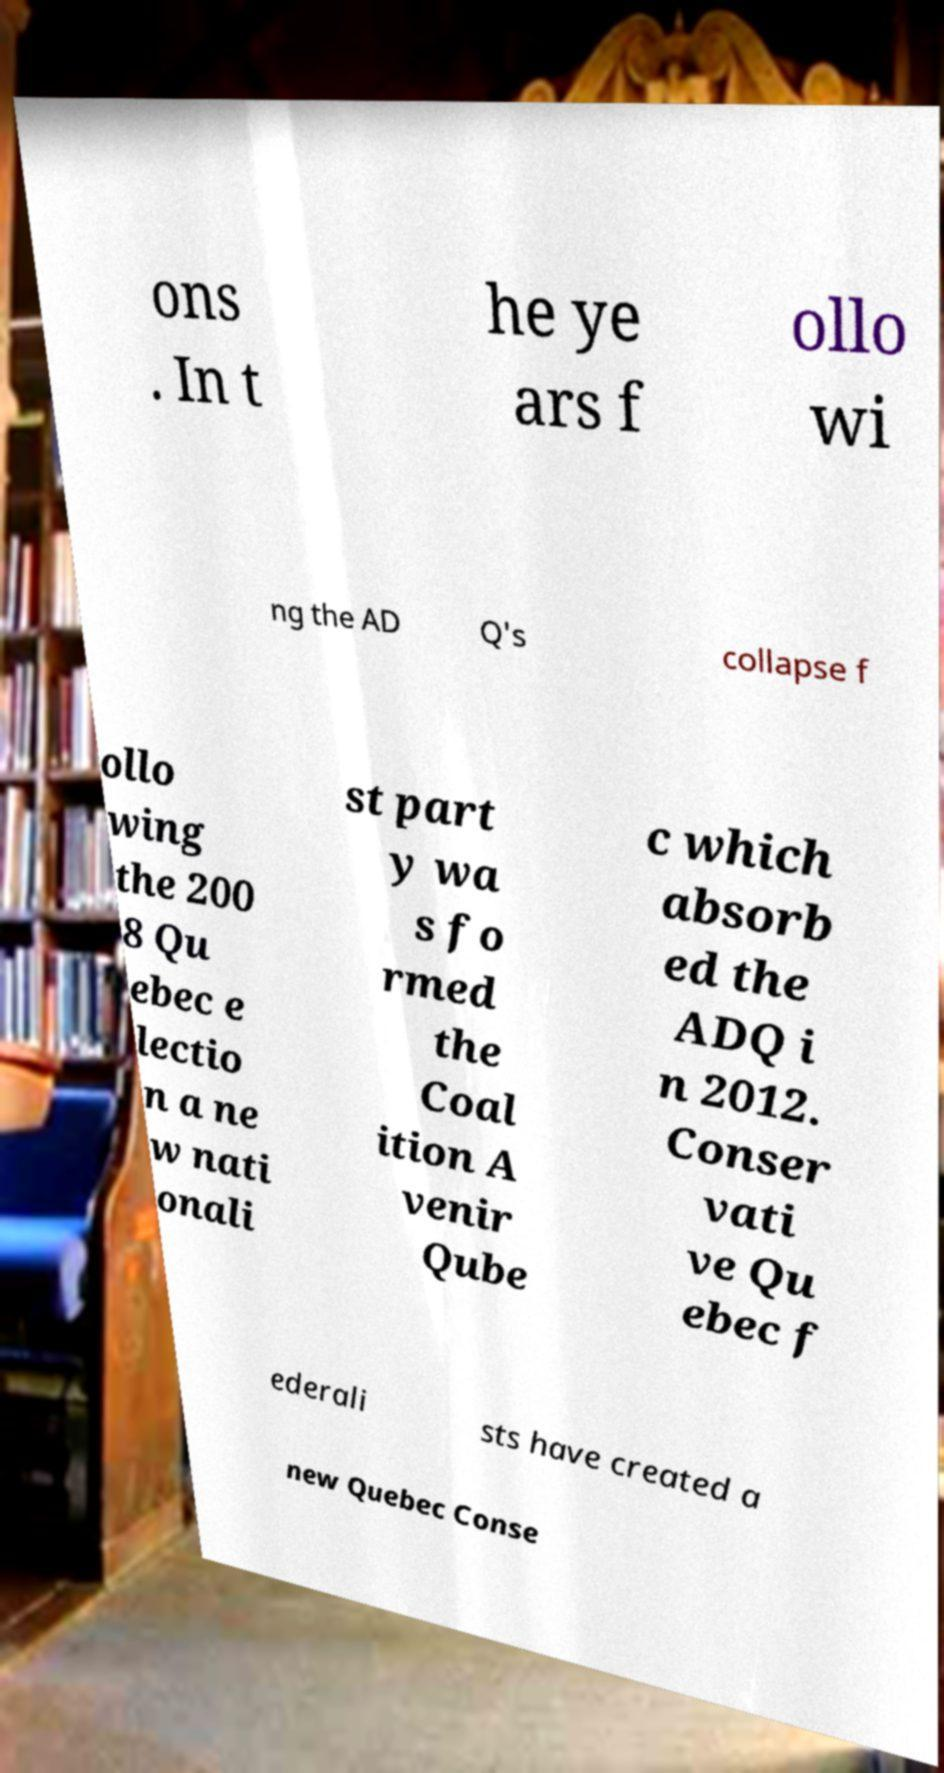Can you read and provide the text displayed in the image?This photo seems to have some interesting text. Can you extract and type it out for me? ons . In t he ye ars f ollo wi ng the AD Q's collapse f ollo wing the 200 8 Qu ebec e lectio n a ne w nati onali st part y wa s fo rmed the Coal ition A venir Qube c which absorb ed the ADQ i n 2012. Conser vati ve Qu ebec f ederali sts have created a new Quebec Conse 